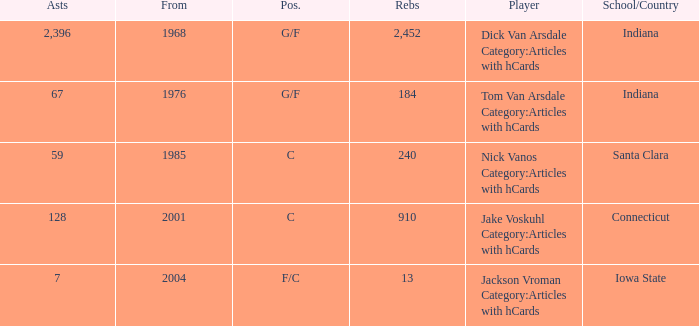What is the highest number of assists for players that are f/c and have under 13 rebounds? None. 